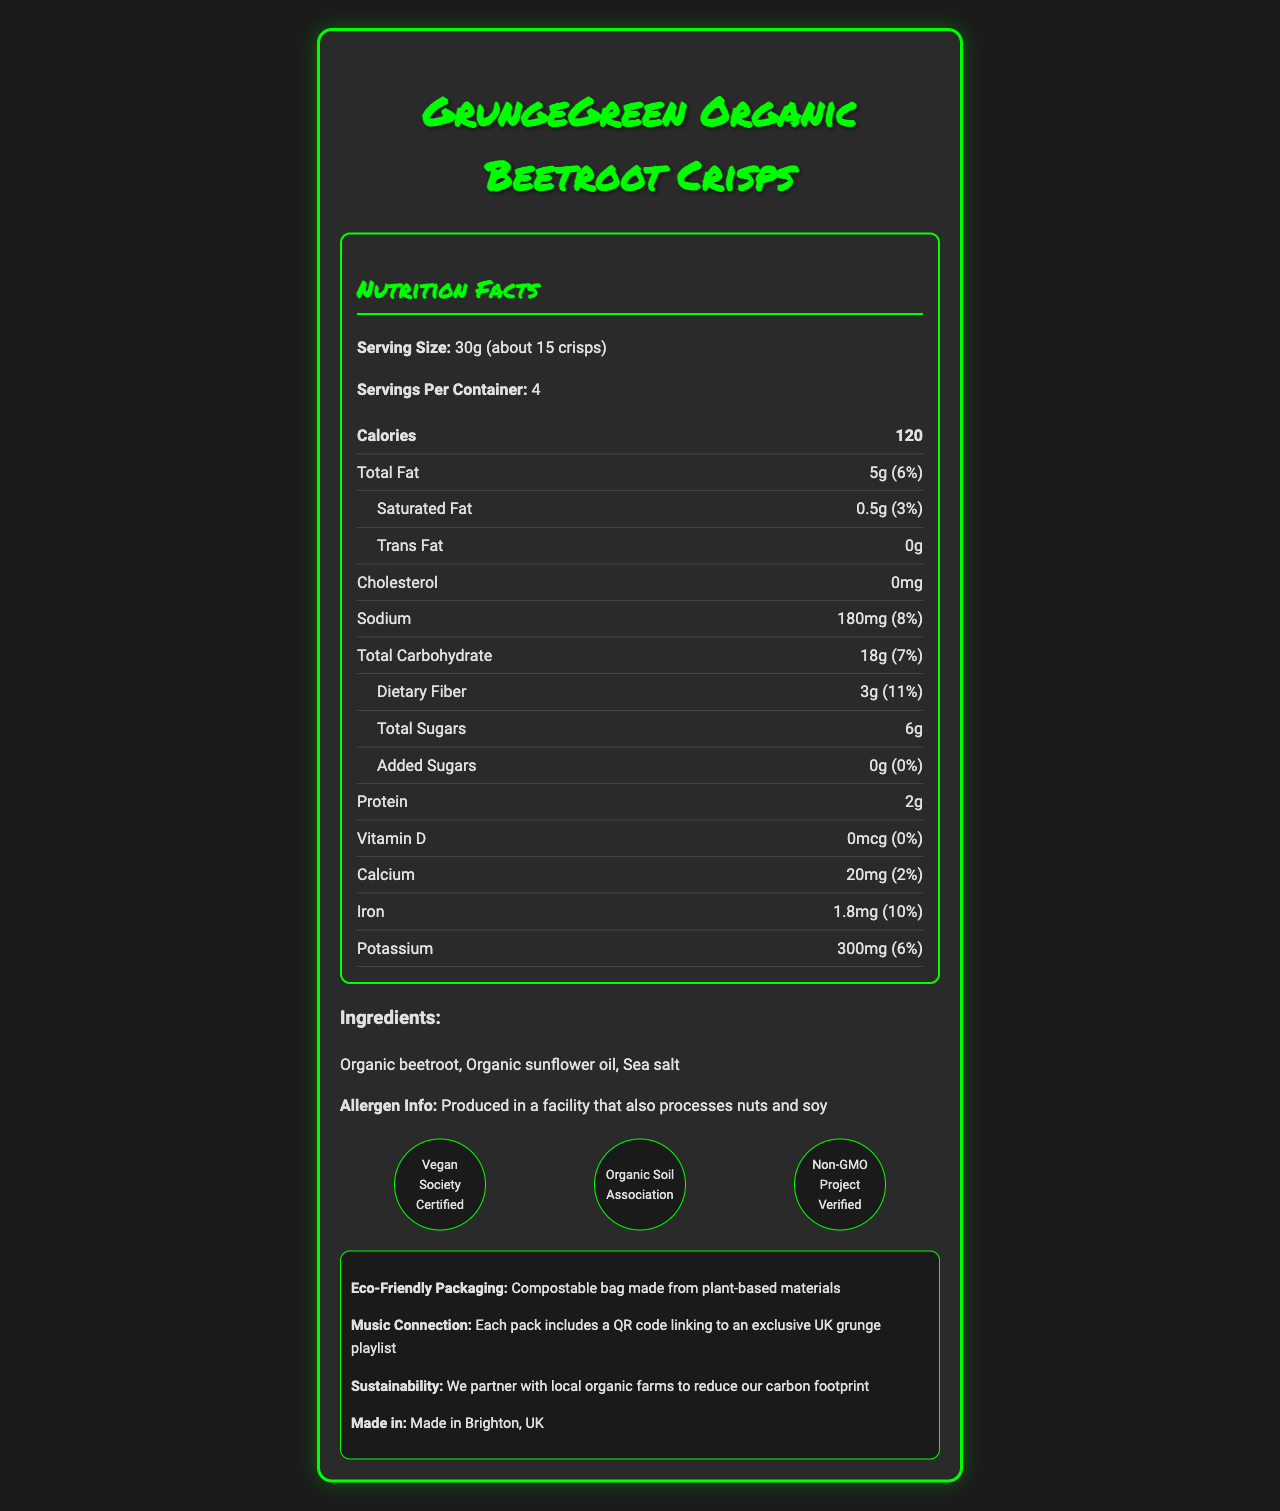what is the serving size per container? The serving size information is given in the document under "Nutrition Facts", where it states "Serving Size: 30g (about 15 crisps)".
Answer: 30g (about 15 crisps) how many servings are in each container? The servings per container are directly mentioned in the document under "Nutrition Facts", which states "Servings Per Container: 4".
Answer: 4 what is the total carbohydrate content per serving? The document lists the "Total Carbohydrate" content under "Nutrition Facts" as 18g per serving.
Answer: 18g how much dietary fiber is in one serving? The dietary fiber content is detailed in the "Nutrition Facts" section, showing "Dietary Fiber: 3g".
Answer: 3g which certifications does this product have? The certifications are listed under a separate section titled "certifications" towards the end of the document.
Answer: Vegan Society Certified, Organic Soil Association, Non-GMO Project Verified what percentage of the daily value of sodium does one serving provide? The document specifies the sodium content under "Nutrition Facts" as "Sodium: 180mg (8%)".
Answer: 8% which vitamins or minerals are listed in the document with their percent daily values? The document lists the percent daily values for Vitamin D, Calcium, Iron, and Potassium under "Nutrition Facts".
Answer: Vitamin D (0%), Calcium (2%), Iron (10%), Potassium (6%) what are the ingredients used in this product? The ingredients are stated in a section titled "Ingredients", listing each ingredient used.
Answer: Organic beetroot, Organic sunflower oil, Sea salt what is the primary flavor of the GrungeGreen Organic Beetroot Crisps? The document describes the nutrition content and certifications but does not provide information about the flavor profile.
Answer: Cannot be determined is this product marketed as vegan-friendly? The document states that the product is "Vegan Society Certified" under "certifications", indicating it is vegan-friendly.
Answer: Yes does one serving of this snack contain any cholesterol? The document specifies "Cholesterol: 0mg" under "Nutrition Facts".
Answer: No how many grams of protein are in one serving? The document states under "Nutrition Facts" that each serving contains 2g of protein.
Answer: 2g what eco-friendly feature does the packaging have? The eco-friendly feature is listed under "Eco-Friendly Packaging", stating that the bag is compostable and made from plant-based materials.
Answer: Compostable bag made from plant-based materials how much calcium does one serving provide? A. 10mg B. 20mg C. 30mg D. 40mg The document lists the calcium content under "Nutrition Facts" as 20mg per serving.
Answer: B. 20mg what exclusive item do you get with each pack? A. A discount coupon B. A QR code to a grunge playlist C. A free sample D. A recipe book The document mentions that each pack includes a "QR code linking to an exclusive UK grunge playlist" under "Music Connection".
Answer: B. A QR code to a grunge playlist which of the following minerals has the highest daily value percentage in one serving? i. Calcium ii. Iron iii. Potassium iv. Sodium The document shows the daily values as Calcium (2%), Iron (10%), Potassium (6%), and Sodium (8%), where Iron has the highest percentage.
Answer: ii. Iron is it indicated where the product is made? The document states that the product is "Made in Brighton, UK" under "Eco-Info".
Answer: Yes summarize the main features of the GrungeGreen Organic Beetroot Crisps. This summary captures the essential details including nutritional information, ingredients, certifications, eco-friendly packaging, and the music connection.
Answer: The GrungeGreen Organic Beetroot Crisps are a vegan-friendly and eco-conscious snack made from organic beetroot, organic sunflower oil, and sea salt. Each serving is 30g and contains 120 calories, 5g of total fat, 18g of carbohydrates including 3g of dietary fiber, and 2g of protein. The product has zero cholesterol and is certified by the Vegan Society, Organic Soil Association, and Non-GMO Project. The packaging is compostable, and a QR code linking to an exclusive UK grunge playlist is included. The product is made in Brighton, UK. 